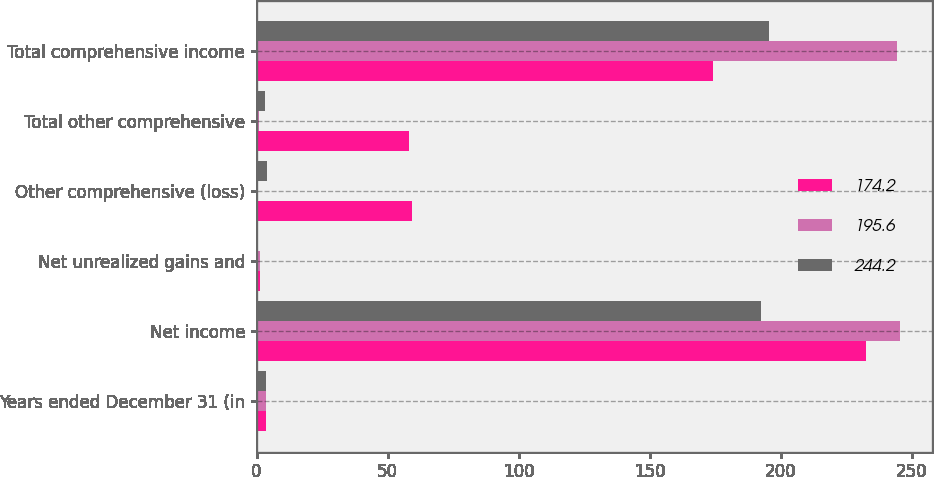<chart> <loc_0><loc_0><loc_500><loc_500><stacked_bar_chart><ecel><fcel>Years ended December 31 (in<fcel>Net income<fcel>Net unrealized gains and<fcel>Other comprehensive (loss)<fcel>Total other comprehensive<fcel>Total comprehensive income<nl><fcel>174.2<fcel>3.65<fcel>232.4<fcel>1.2<fcel>59.2<fcel>58.2<fcel>174.2<nl><fcel>195.6<fcel>3.65<fcel>245.3<fcel>1.3<fcel>0.4<fcel>1.1<fcel>244.2<nl><fcel>244.2<fcel>3.65<fcel>192.4<fcel>0.3<fcel>4.1<fcel>3.2<fcel>195.6<nl></chart> 